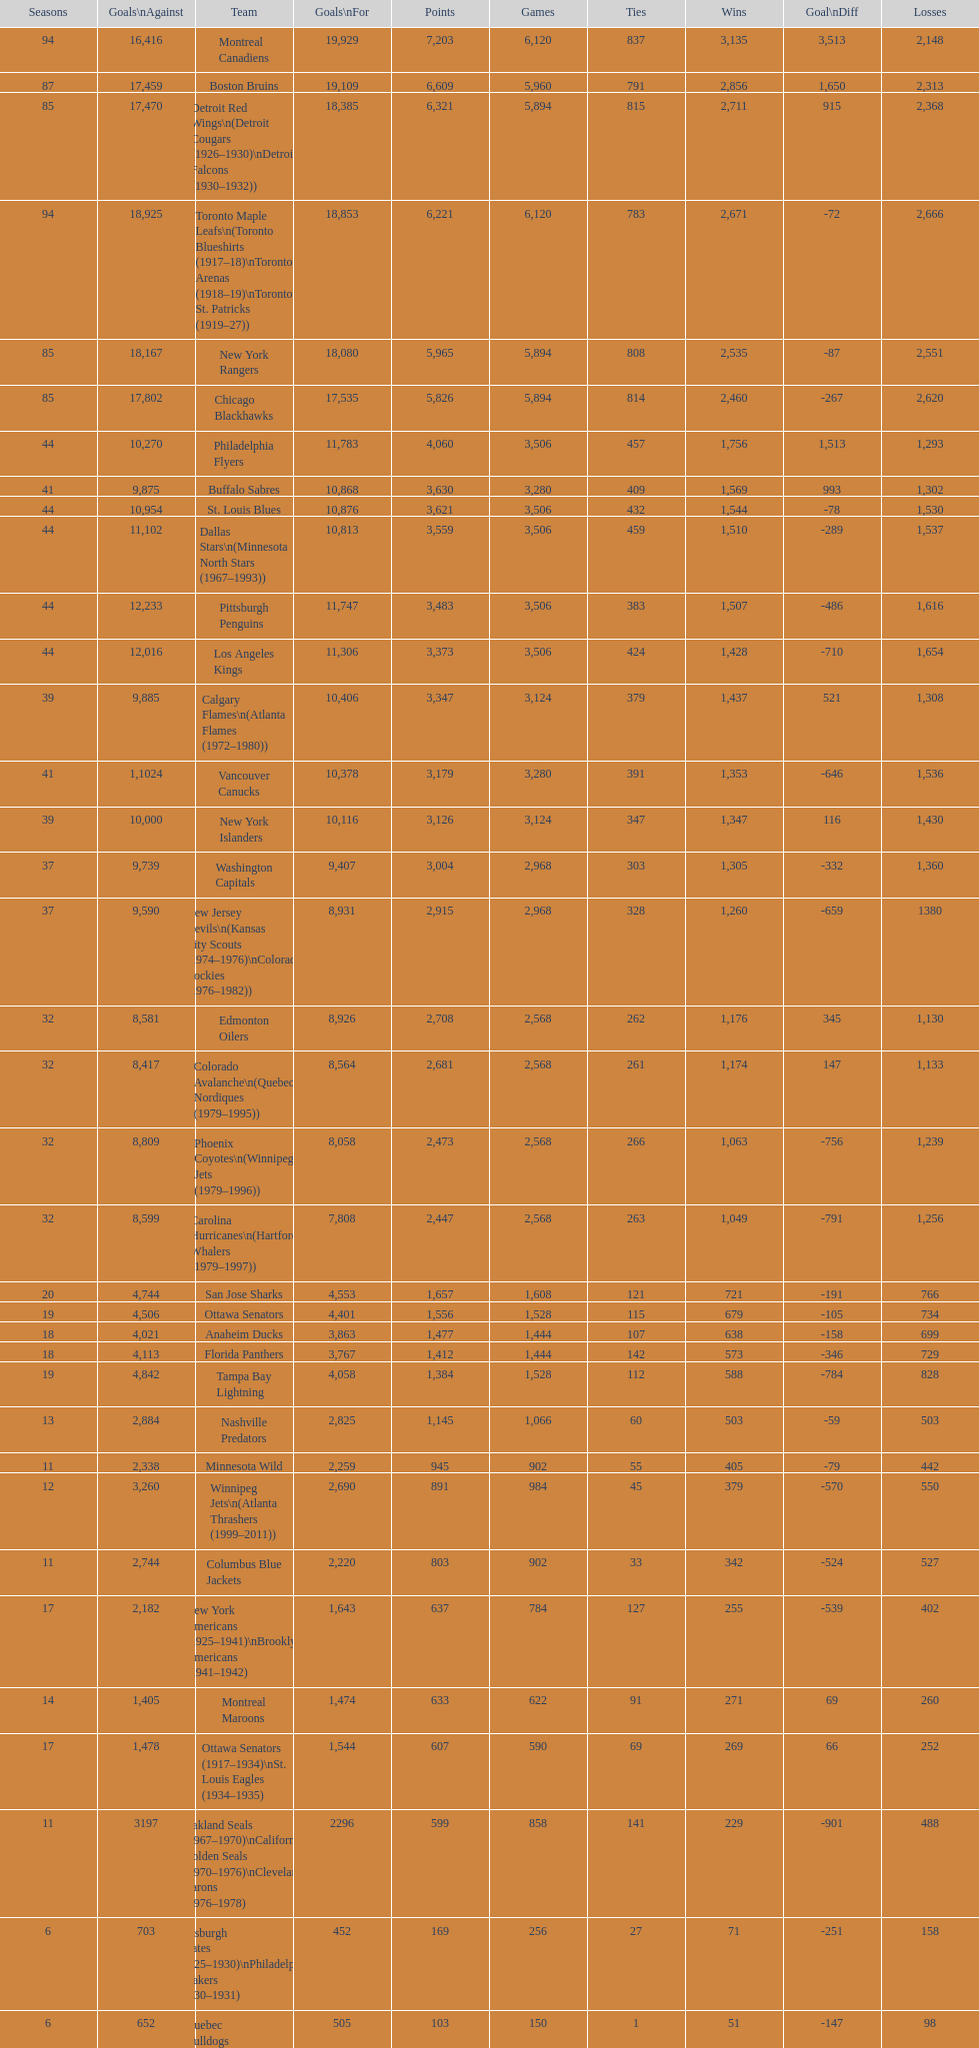Which team was last in terms of points up until this point? Montreal Wanderers. 